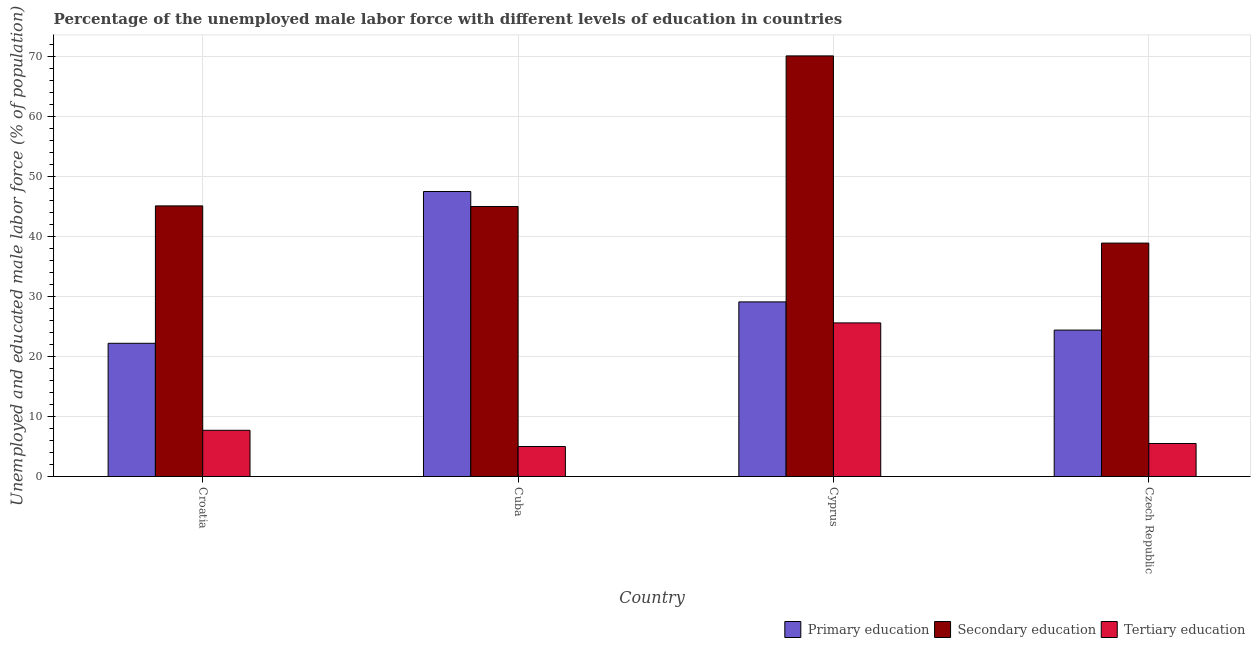How many different coloured bars are there?
Keep it short and to the point. 3. Are the number of bars per tick equal to the number of legend labels?
Your answer should be compact. Yes. How many bars are there on the 2nd tick from the left?
Offer a very short reply. 3. What is the label of the 3rd group of bars from the left?
Your response must be concise. Cyprus. In how many cases, is the number of bars for a given country not equal to the number of legend labels?
Make the answer very short. 0. What is the percentage of male labor force who received primary education in Cyprus?
Give a very brief answer. 29.1. Across all countries, what is the maximum percentage of male labor force who received primary education?
Make the answer very short. 47.5. Across all countries, what is the minimum percentage of male labor force who received primary education?
Keep it short and to the point. 22.2. In which country was the percentage of male labor force who received primary education maximum?
Ensure brevity in your answer.  Cuba. In which country was the percentage of male labor force who received tertiary education minimum?
Give a very brief answer. Cuba. What is the total percentage of male labor force who received primary education in the graph?
Provide a succinct answer. 123.2. What is the difference between the percentage of male labor force who received primary education in Croatia and that in Cyprus?
Keep it short and to the point. -6.9. What is the difference between the percentage of male labor force who received primary education in Cuba and the percentage of male labor force who received secondary education in Czech Republic?
Give a very brief answer. 8.6. What is the average percentage of male labor force who received primary education per country?
Offer a terse response. 30.8. What is the difference between the percentage of male labor force who received tertiary education and percentage of male labor force who received secondary education in Czech Republic?
Keep it short and to the point. -33.4. What is the ratio of the percentage of male labor force who received tertiary education in Croatia to that in Cyprus?
Your answer should be compact. 0.3. What is the difference between the highest and the second highest percentage of male labor force who received secondary education?
Provide a short and direct response. 25. What is the difference between the highest and the lowest percentage of male labor force who received tertiary education?
Your answer should be very brief. 20.6. Is the sum of the percentage of male labor force who received secondary education in Croatia and Czech Republic greater than the maximum percentage of male labor force who received primary education across all countries?
Offer a terse response. Yes. What does the 2nd bar from the left in Cyprus represents?
Ensure brevity in your answer.  Secondary education. What does the 3rd bar from the right in Czech Republic represents?
Ensure brevity in your answer.  Primary education. Are all the bars in the graph horizontal?
Give a very brief answer. No. How many countries are there in the graph?
Your response must be concise. 4. Are the values on the major ticks of Y-axis written in scientific E-notation?
Your answer should be very brief. No. Does the graph contain grids?
Keep it short and to the point. Yes. How are the legend labels stacked?
Provide a succinct answer. Horizontal. What is the title of the graph?
Your response must be concise. Percentage of the unemployed male labor force with different levels of education in countries. Does "Textiles and clothing" appear as one of the legend labels in the graph?
Make the answer very short. No. What is the label or title of the X-axis?
Provide a succinct answer. Country. What is the label or title of the Y-axis?
Provide a short and direct response. Unemployed and educated male labor force (% of population). What is the Unemployed and educated male labor force (% of population) of Primary education in Croatia?
Keep it short and to the point. 22.2. What is the Unemployed and educated male labor force (% of population) of Secondary education in Croatia?
Your answer should be compact. 45.1. What is the Unemployed and educated male labor force (% of population) in Tertiary education in Croatia?
Your response must be concise. 7.7. What is the Unemployed and educated male labor force (% of population) in Primary education in Cuba?
Offer a terse response. 47.5. What is the Unemployed and educated male labor force (% of population) in Tertiary education in Cuba?
Ensure brevity in your answer.  5. What is the Unemployed and educated male labor force (% of population) in Primary education in Cyprus?
Give a very brief answer. 29.1. What is the Unemployed and educated male labor force (% of population) of Secondary education in Cyprus?
Offer a terse response. 70.1. What is the Unemployed and educated male labor force (% of population) in Tertiary education in Cyprus?
Ensure brevity in your answer.  25.6. What is the Unemployed and educated male labor force (% of population) in Primary education in Czech Republic?
Make the answer very short. 24.4. What is the Unemployed and educated male labor force (% of population) in Secondary education in Czech Republic?
Offer a very short reply. 38.9. What is the Unemployed and educated male labor force (% of population) in Tertiary education in Czech Republic?
Give a very brief answer. 5.5. Across all countries, what is the maximum Unemployed and educated male labor force (% of population) in Primary education?
Ensure brevity in your answer.  47.5. Across all countries, what is the maximum Unemployed and educated male labor force (% of population) in Secondary education?
Make the answer very short. 70.1. Across all countries, what is the maximum Unemployed and educated male labor force (% of population) in Tertiary education?
Your response must be concise. 25.6. Across all countries, what is the minimum Unemployed and educated male labor force (% of population) of Primary education?
Your answer should be compact. 22.2. Across all countries, what is the minimum Unemployed and educated male labor force (% of population) in Secondary education?
Your answer should be compact. 38.9. Across all countries, what is the minimum Unemployed and educated male labor force (% of population) of Tertiary education?
Make the answer very short. 5. What is the total Unemployed and educated male labor force (% of population) of Primary education in the graph?
Your answer should be very brief. 123.2. What is the total Unemployed and educated male labor force (% of population) in Secondary education in the graph?
Provide a succinct answer. 199.1. What is the total Unemployed and educated male labor force (% of population) of Tertiary education in the graph?
Ensure brevity in your answer.  43.8. What is the difference between the Unemployed and educated male labor force (% of population) of Primary education in Croatia and that in Cuba?
Offer a very short reply. -25.3. What is the difference between the Unemployed and educated male labor force (% of population) of Tertiary education in Croatia and that in Cuba?
Provide a short and direct response. 2.7. What is the difference between the Unemployed and educated male labor force (% of population) of Secondary education in Croatia and that in Cyprus?
Your response must be concise. -25. What is the difference between the Unemployed and educated male labor force (% of population) of Tertiary education in Croatia and that in Cyprus?
Your answer should be compact. -17.9. What is the difference between the Unemployed and educated male labor force (% of population) of Primary education in Croatia and that in Czech Republic?
Give a very brief answer. -2.2. What is the difference between the Unemployed and educated male labor force (% of population) of Secondary education in Croatia and that in Czech Republic?
Your answer should be compact. 6.2. What is the difference between the Unemployed and educated male labor force (% of population) of Primary education in Cuba and that in Cyprus?
Your answer should be very brief. 18.4. What is the difference between the Unemployed and educated male labor force (% of population) in Secondary education in Cuba and that in Cyprus?
Your response must be concise. -25.1. What is the difference between the Unemployed and educated male labor force (% of population) of Tertiary education in Cuba and that in Cyprus?
Give a very brief answer. -20.6. What is the difference between the Unemployed and educated male labor force (% of population) in Primary education in Cuba and that in Czech Republic?
Your response must be concise. 23.1. What is the difference between the Unemployed and educated male labor force (% of population) of Secondary education in Cuba and that in Czech Republic?
Your answer should be compact. 6.1. What is the difference between the Unemployed and educated male labor force (% of population) in Tertiary education in Cuba and that in Czech Republic?
Offer a terse response. -0.5. What is the difference between the Unemployed and educated male labor force (% of population) of Primary education in Cyprus and that in Czech Republic?
Provide a short and direct response. 4.7. What is the difference between the Unemployed and educated male labor force (% of population) in Secondary education in Cyprus and that in Czech Republic?
Keep it short and to the point. 31.2. What is the difference between the Unemployed and educated male labor force (% of population) of Tertiary education in Cyprus and that in Czech Republic?
Offer a terse response. 20.1. What is the difference between the Unemployed and educated male labor force (% of population) of Primary education in Croatia and the Unemployed and educated male labor force (% of population) of Secondary education in Cuba?
Your answer should be very brief. -22.8. What is the difference between the Unemployed and educated male labor force (% of population) in Secondary education in Croatia and the Unemployed and educated male labor force (% of population) in Tertiary education in Cuba?
Provide a short and direct response. 40.1. What is the difference between the Unemployed and educated male labor force (% of population) in Primary education in Croatia and the Unemployed and educated male labor force (% of population) in Secondary education in Cyprus?
Make the answer very short. -47.9. What is the difference between the Unemployed and educated male labor force (% of population) of Primary education in Croatia and the Unemployed and educated male labor force (% of population) of Tertiary education in Cyprus?
Give a very brief answer. -3.4. What is the difference between the Unemployed and educated male labor force (% of population) in Primary education in Croatia and the Unemployed and educated male labor force (% of population) in Secondary education in Czech Republic?
Give a very brief answer. -16.7. What is the difference between the Unemployed and educated male labor force (% of population) in Primary education in Croatia and the Unemployed and educated male labor force (% of population) in Tertiary education in Czech Republic?
Your response must be concise. 16.7. What is the difference between the Unemployed and educated male labor force (% of population) of Secondary education in Croatia and the Unemployed and educated male labor force (% of population) of Tertiary education in Czech Republic?
Give a very brief answer. 39.6. What is the difference between the Unemployed and educated male labor force (% of population) in Primary education in Cuba and the Unemployed and educated male labor force (% of population) in Secondary education in Cyprus?
Your answer should be very brief. -22.6. What is the difference between the Unemployed and educated male labor force (% of population) of Primary education in Cuba and the Unemployed and educated male labor force (% of population) of Tertiary education in Cyprus?
Your response must be concise. 21.9. What is the difference between the Unemployed and educated male labor force (% of population) of Secondary education in Cuba and the Unemployed and educated male labor force (% of population) of Tertiary education in Cyprus?
Offer a terse response. 19.4. What is the difference between the Unemployed and educated male labor force (% of population) of Primary education in Cuba and the Unemployed and educated male labor force (% of population) of Tertiary education in Czech Republic?
Offer a terse response. 42. What is the difference between the Unemployed and educated male labor force (% of population) of Secondary education in Cuba and the Unemployed and educated male labor force (% of population) of Tertiary education in Czech Republic?
Provide a short and direct response. 39.5. What is the difference between the Unemployed and educated male labor force (% of population) of Primary education in Cyprus and the Unemployed and educated male labor force (% of population) of Secondary education in Czech Republic?
Keep it short and to the point. -9.8. What is the difference between the Unemployed and educated male labor force (% of population) in Primary education in Cyprus and the Unemployed and educated male labor force (% of population) in Tertiary education in Czech Republic?
Provide a short and direct response. 23.6. What is the difference between the Unemployed and educated male labor force (% of population) in Secondary education in Cyprus and the Unemployed and educated male labor force (% of population) in Tertiary education in Czech Republic?
Provide a succinct answer. 64.6. What is the average Unemployed and educated male labor force (% of population) in Primary education per country?
Ensure brevity in your answer.  30.8. What is the average Unemployed and educated male labor force (% of population) of Secondary education per country?
Offer a very short reply. 49.77. What is the average Unemployed and educated male labor force (% of population) in Tertiary education per country?
Keep it short and to the point. 10.95. What is the difference between the Unemployed and educated male labor force (% of population) in Primary education and Unemployed and educated male labor force (% of population) in Secondary education in Croatia?
Your answer should be very brief. -22.9. What is the difference between the Unemployed and educated male labor force (% of population) of Secondary education and Unemployed and educated male labor force (% of population) of Tertiary education in Croatia?
Make the answer very short. 37.4. What is the difference between the Unemployed and educated male labor force (% of population) of Primary education and Unemployed and educated male labor force (% of population) of Tertiary education in Cuba?
Offer a terse response. 42.5. What is the difference between the Unemployed and educated male labor force (% of population) in Primary education and Unemployed and educated male labor force (% of population) in Secondary education in Cyprus?
Keep it short and to the point. -41. What is the difference between the Unemployed and educated male labor force (% of population) in Secondary education and Unemployed and educated male labor force (% of population) in Tertiary education in Cyprus?
Your response must be concise. 44.5. What is the difference between the Unemployed and educated male labor force (% of population) of Primary education and Unemployed and educated male labor force (% of population) of Secondary education in Czech Republic?
Make the answer very short. -14.5. What is the difference between the Unemployed and educated male labor force (% of population) in Secondary education and Unemployed and educated male labor force (% of population) in Tertiary education in Czech Republic?
Your answer should be compact. 33.4. What is the ratio of the Unemployed and educated male labor force (% of population) in Primary education in Croatia to that in Cuba?
Your answer should be compact. 0.47. What is the ratio of the Unemployed and educated male labor force (% of population) of Secondary education in Croatia to that in Cuba?
Make the answer very short. 1. What is the ratio of the Unemployed and educated male labor force (% of population) in Tertiary education in Croatia to that in Cuba?
Provide a succinct answer. 1.54. What is the ratio of the Unemployed and educated male labor force (% of population) of Primary education in Croatia to that in Cyprus?
Make the answer very short. 0.76. What is the ratio of the Unemployed and educated male labor force (% of population) of Secondary education in Croatia to that in Cyprus?
Give a very brief answer. 0.64. What is the ratio of the Unemployed and educated male labor force (% of population) in Tertiary education in Croatia to that in Cyprus?
Offer a terse response. 0.3. What is the ratio of the Unemployed and educated male labor force (% of population) in Primary education in Croatia to that in Czech Republic?
Your answer should be compact. 0.91. What is the ratio of the Unemployed and educated male labor force (% of population) in Secondary education in Croatia to that in Czech Republic?
Your answer should be very brief. 1.16. What is the ratio of the Unemployed and educated male labor force (% of population) of Tertiary education in Croatia to that in Czech Republic?
Your answer should be compact. 1.4. What is the ratio of the Unemployed and educated male labor force (% of population) of Primary education in Cuba to that in Cyprus?
Provide a short and direct response. 1.63. What is the ratio of the Unemployed and educated male labor force (% of population) of Secondary education in Cuba to that in Cyprus?
Your answer should be very brief. 0.64. What is the ratio of the Unemployed and educated male labor force (% of population) of Tertiary education in Cuba to that in Cyprus?
Make the answer very short. 0.2. What is the ratio of the Unemployed and educated male labor force (% of population) of Primary education in Cuba to that in Czech Republic?
Provide a short and direct response. 1.95. What is the ratio of the Unemployed and educated male labor force (% of population) in Secondary education in Cuba to that in Czech Republic?
Your answer should be compact. 1.16. What is the ratio of the Unemployed and educated male labor force (% of population) in Primary education in Cyprus to that in Czech Republic?
Ensure brevity in your answer.  1.19. What is the ratio of the Unemployed and educated male labor force (% of population) of Secondary education in Cyprus to that in Czech Republic?
Your response must be concise. 1.8. What is the ratio of the Unemployed and educated male labor force (% of population) of Tertiary education in Cyprus to that in Czech Republic?
Offer a very short reply. 4.65. What is the difference between the highest and the second highest Unemployed and educated male labor force (% of population) in Primary education?
Offer a very short reply. 18.4. What is the difference between the highest and the second highest Unemployed and educated male labor force (% of population) in Secondary education?
Offer a terse response. 25. What is the difference between the highest and the lowest Unemployed and educated male labor force (% of population) of Primary education?
Your answer should be very brief. 25.3. What is the difference between the highest and the lowest Unemployed and educated male labor force (% of population) of Secondary education?
Your response must be concise. 31.2. What is the difference between the highest and the lowest Unemployed and educated male labor force (% of population) in Tertiary education?
Your answer should be compact. 20.6. 